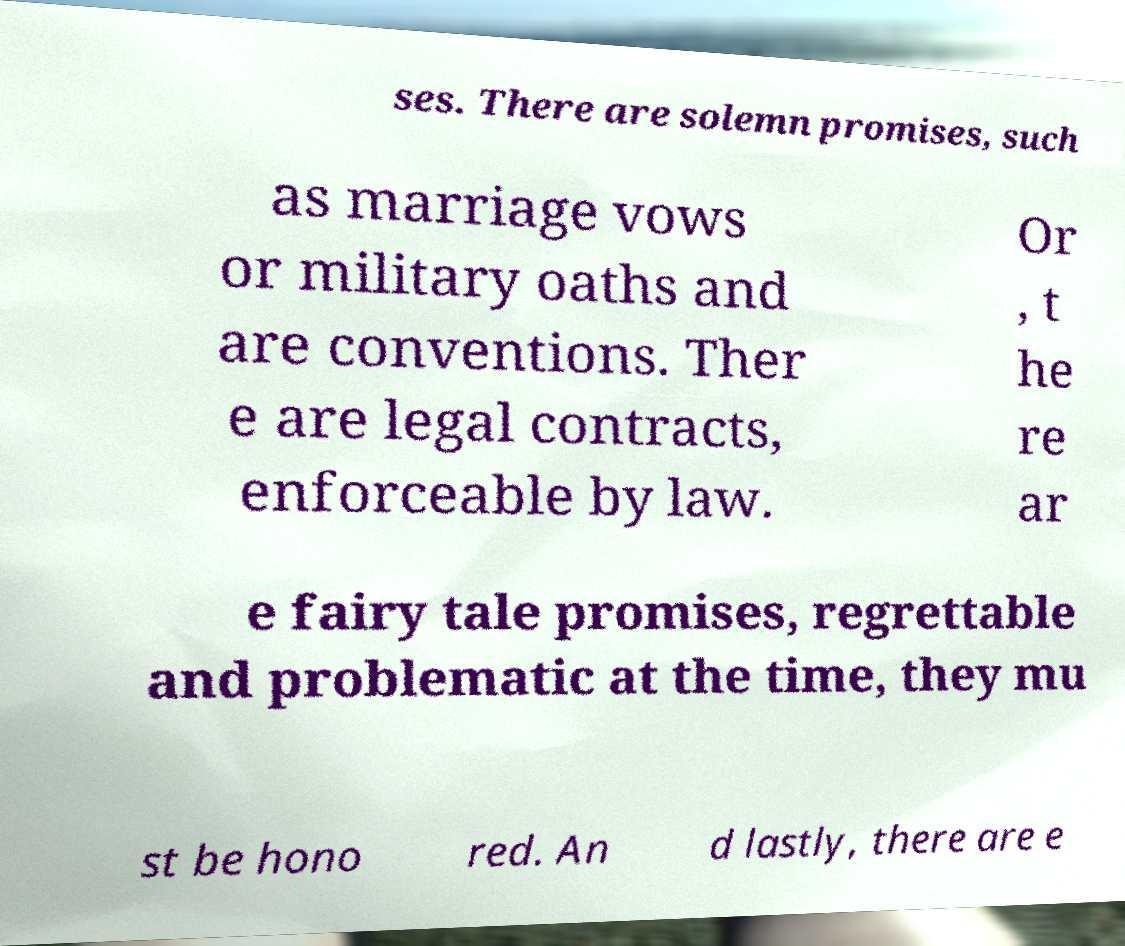I need the written content from this picture converted into text. Can you do that? ses. There are solemn promises, such as marriage vows or military oaths and are conventions. Ther e are legal contracts, enforceable by law. Or , t he re ar e fairy tale promises, regrettable and problematic at the time, they mu st be hono red. An d lastly, there are e 